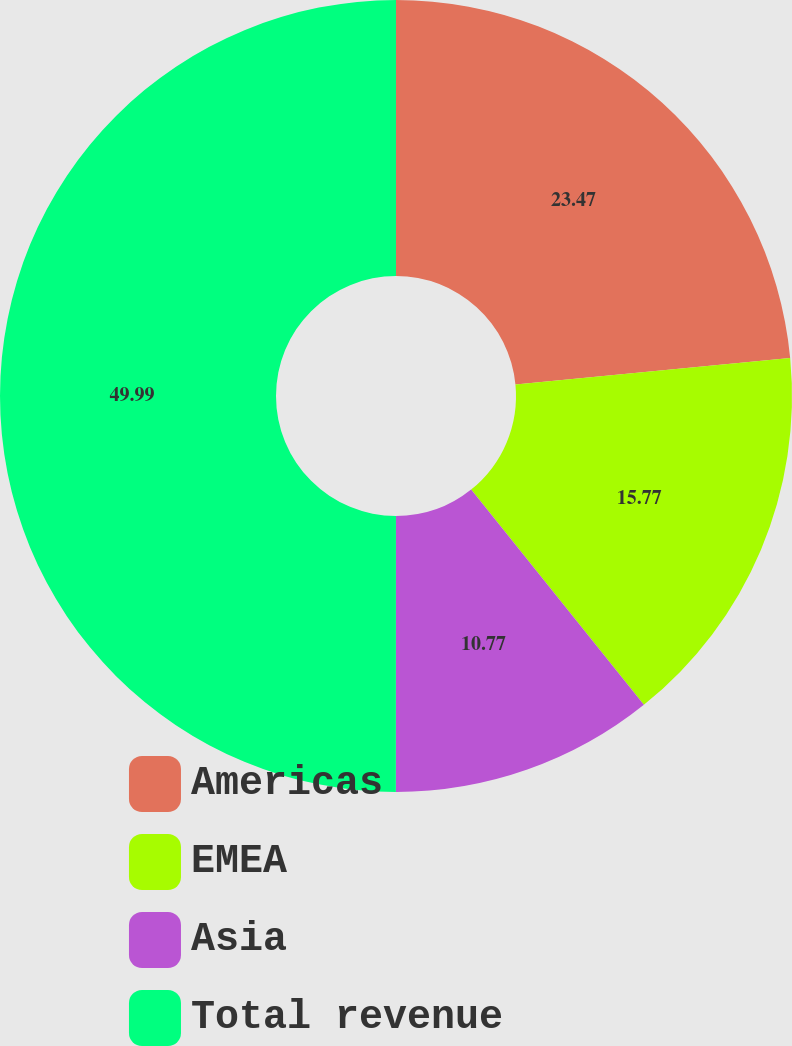<chart> <loc_0><loc_0><loc_500><loc_500><pie_chart><fcel>Americas<fcel>EMEA<fcel>Asia<fcel>Total revenue<nl><fcel>23.47%<fcel>15.77%<fcel>10.77%<fcel>50.0%<nl></chart> 